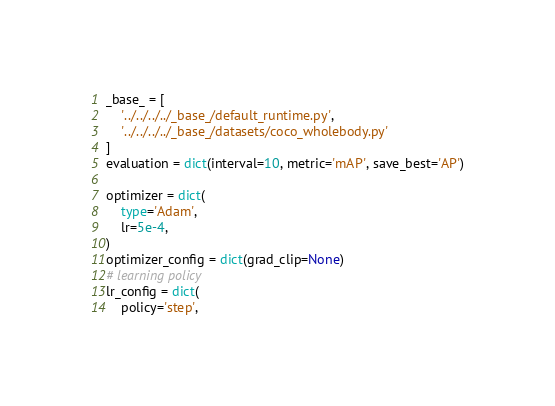<code> <loc_0><loc_0><loc_500><loc_500><_Python_>_base_ = [
    '../../../../_base_/default_runtime.py',
    '../../../../_base_/datasets/coco_wholebody.py'
]
evaluation = dict(interval=10, metric='mAP', save_best='AP')

optimizer = dict(
    type='Adam',
    lr=5e-4,
)
optimizer_config = dict(grad_clip=None)
# learning policy
lr_config = dict(
    policy='step',</code> 